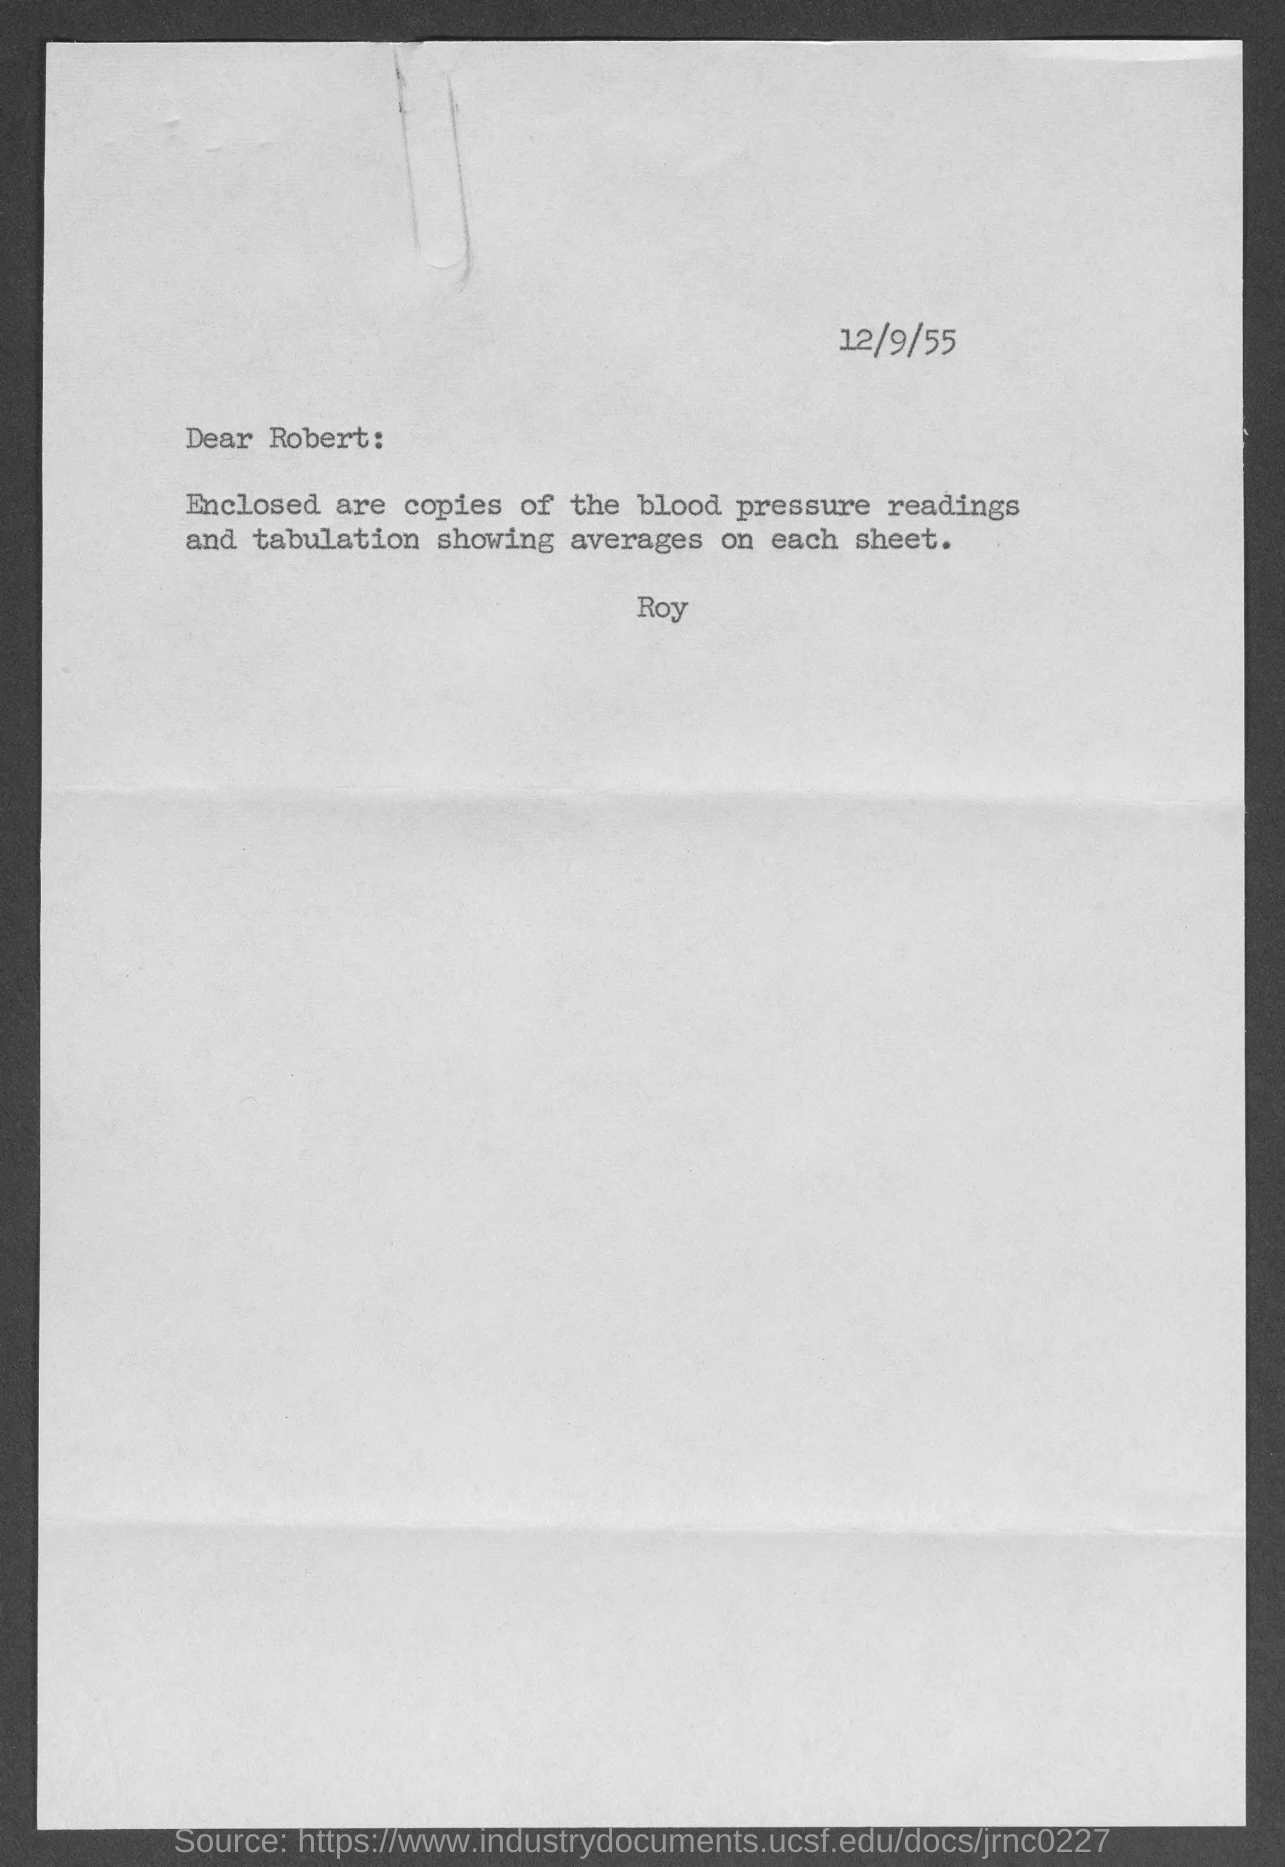What is the date at top of the page?
Give a very brief answer. 12/9/55. 